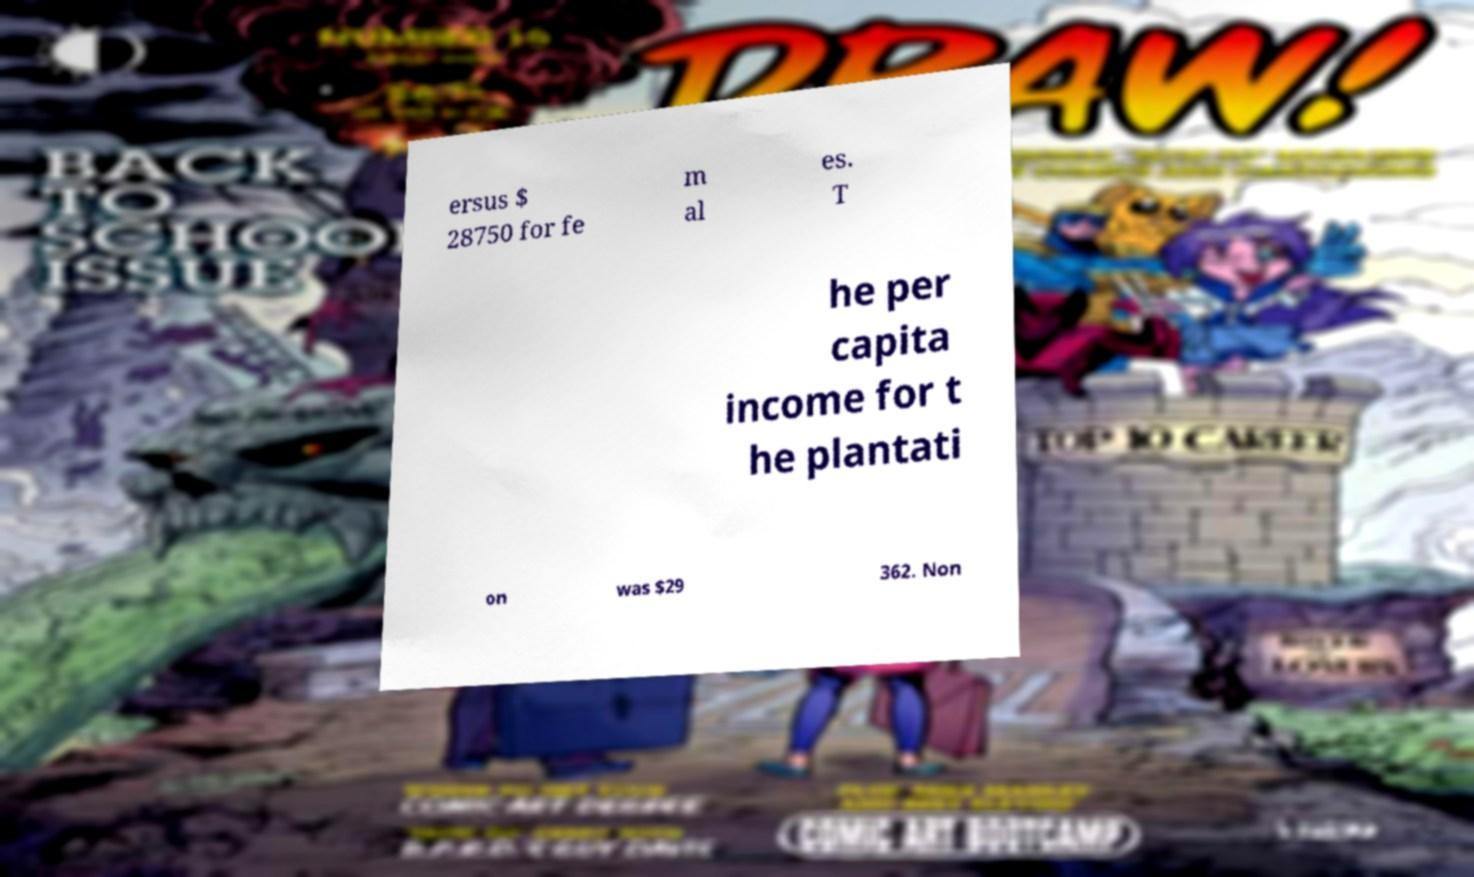For documentation purposes, I need the text within this image transcribed. Could you provide that? ersus $ 28750 for fe m al es. T he per capita income for t he plantati on was $29 362. Non 